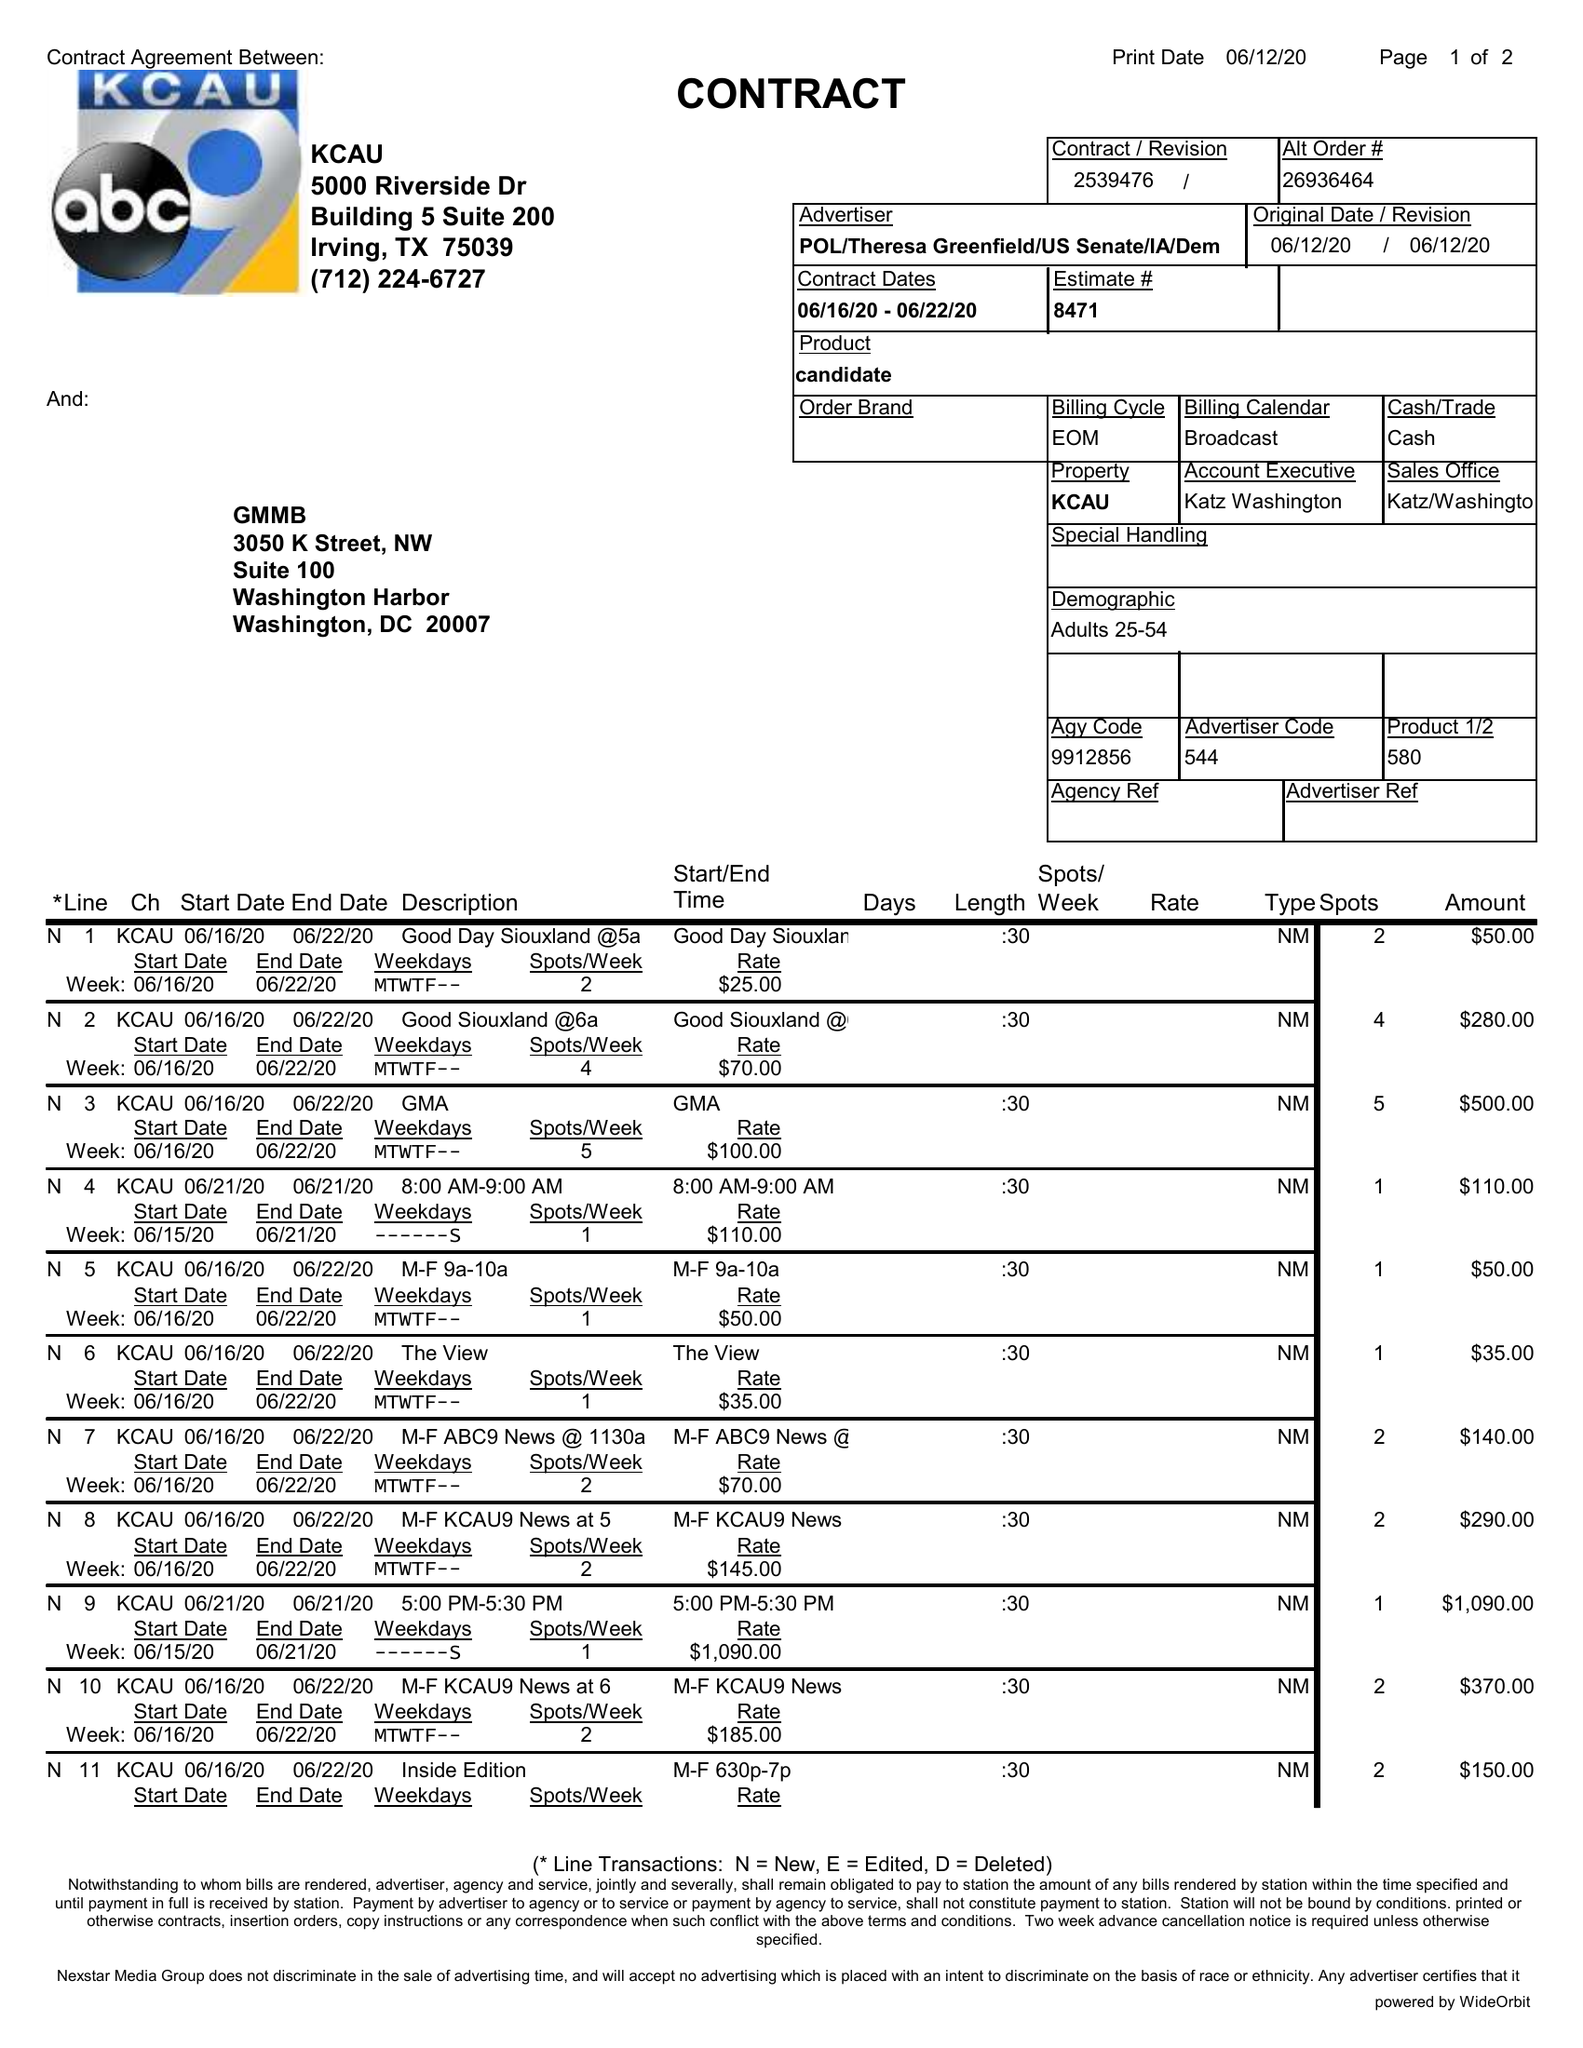What is the value for the contract_num?
Answer the question using a single word or phrase. 2539476 